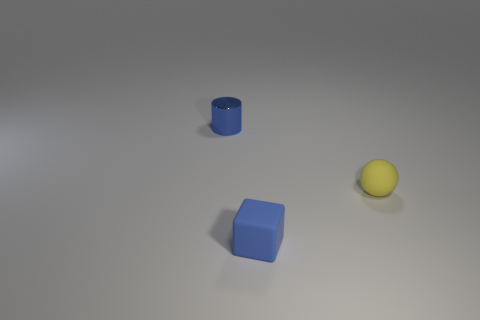Do the yellow thing and the blue thing on the right side of the blue metallic thing have the same material?
Provide a succinct answer. Yes. How many blue objects are either large rubber balls or tiny rubber blocks?
Give a very brief answer. 1. The blue thing that is made of the same material as the small ball is what size?
Offer a very short reply. Small. Are there more small rubber objects that are in front of the yellow thing than yellow rubber spheres that are in front of the blue cube?
Offer a terse response. Yes. Is the color of the matte block the same as the thing behind the tiny rubber sphere?
Your answer should be very brief. Yes. There is a cylinder that is the same size as the yellow sphere; what is its material?
Ensure brevity in your answer.  Metal. How many things are shiny things or tiny blue objects on the left side of the ball?
Make the answer very short. 2. Does the blue block have the same size as the blue thing that is to the left of the tiny blue cube?
Your answer should be compact. Yes. What number of cylinders are blue metallic objects or small yellow things?
Provide a succinct answer. 1. How many small things are to the left of the small blue rubber thing and to the right of the blue matte thing?
Provide a short and direct response. 0. 